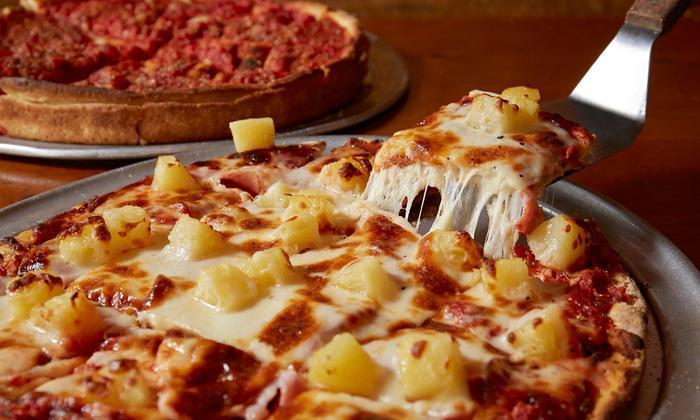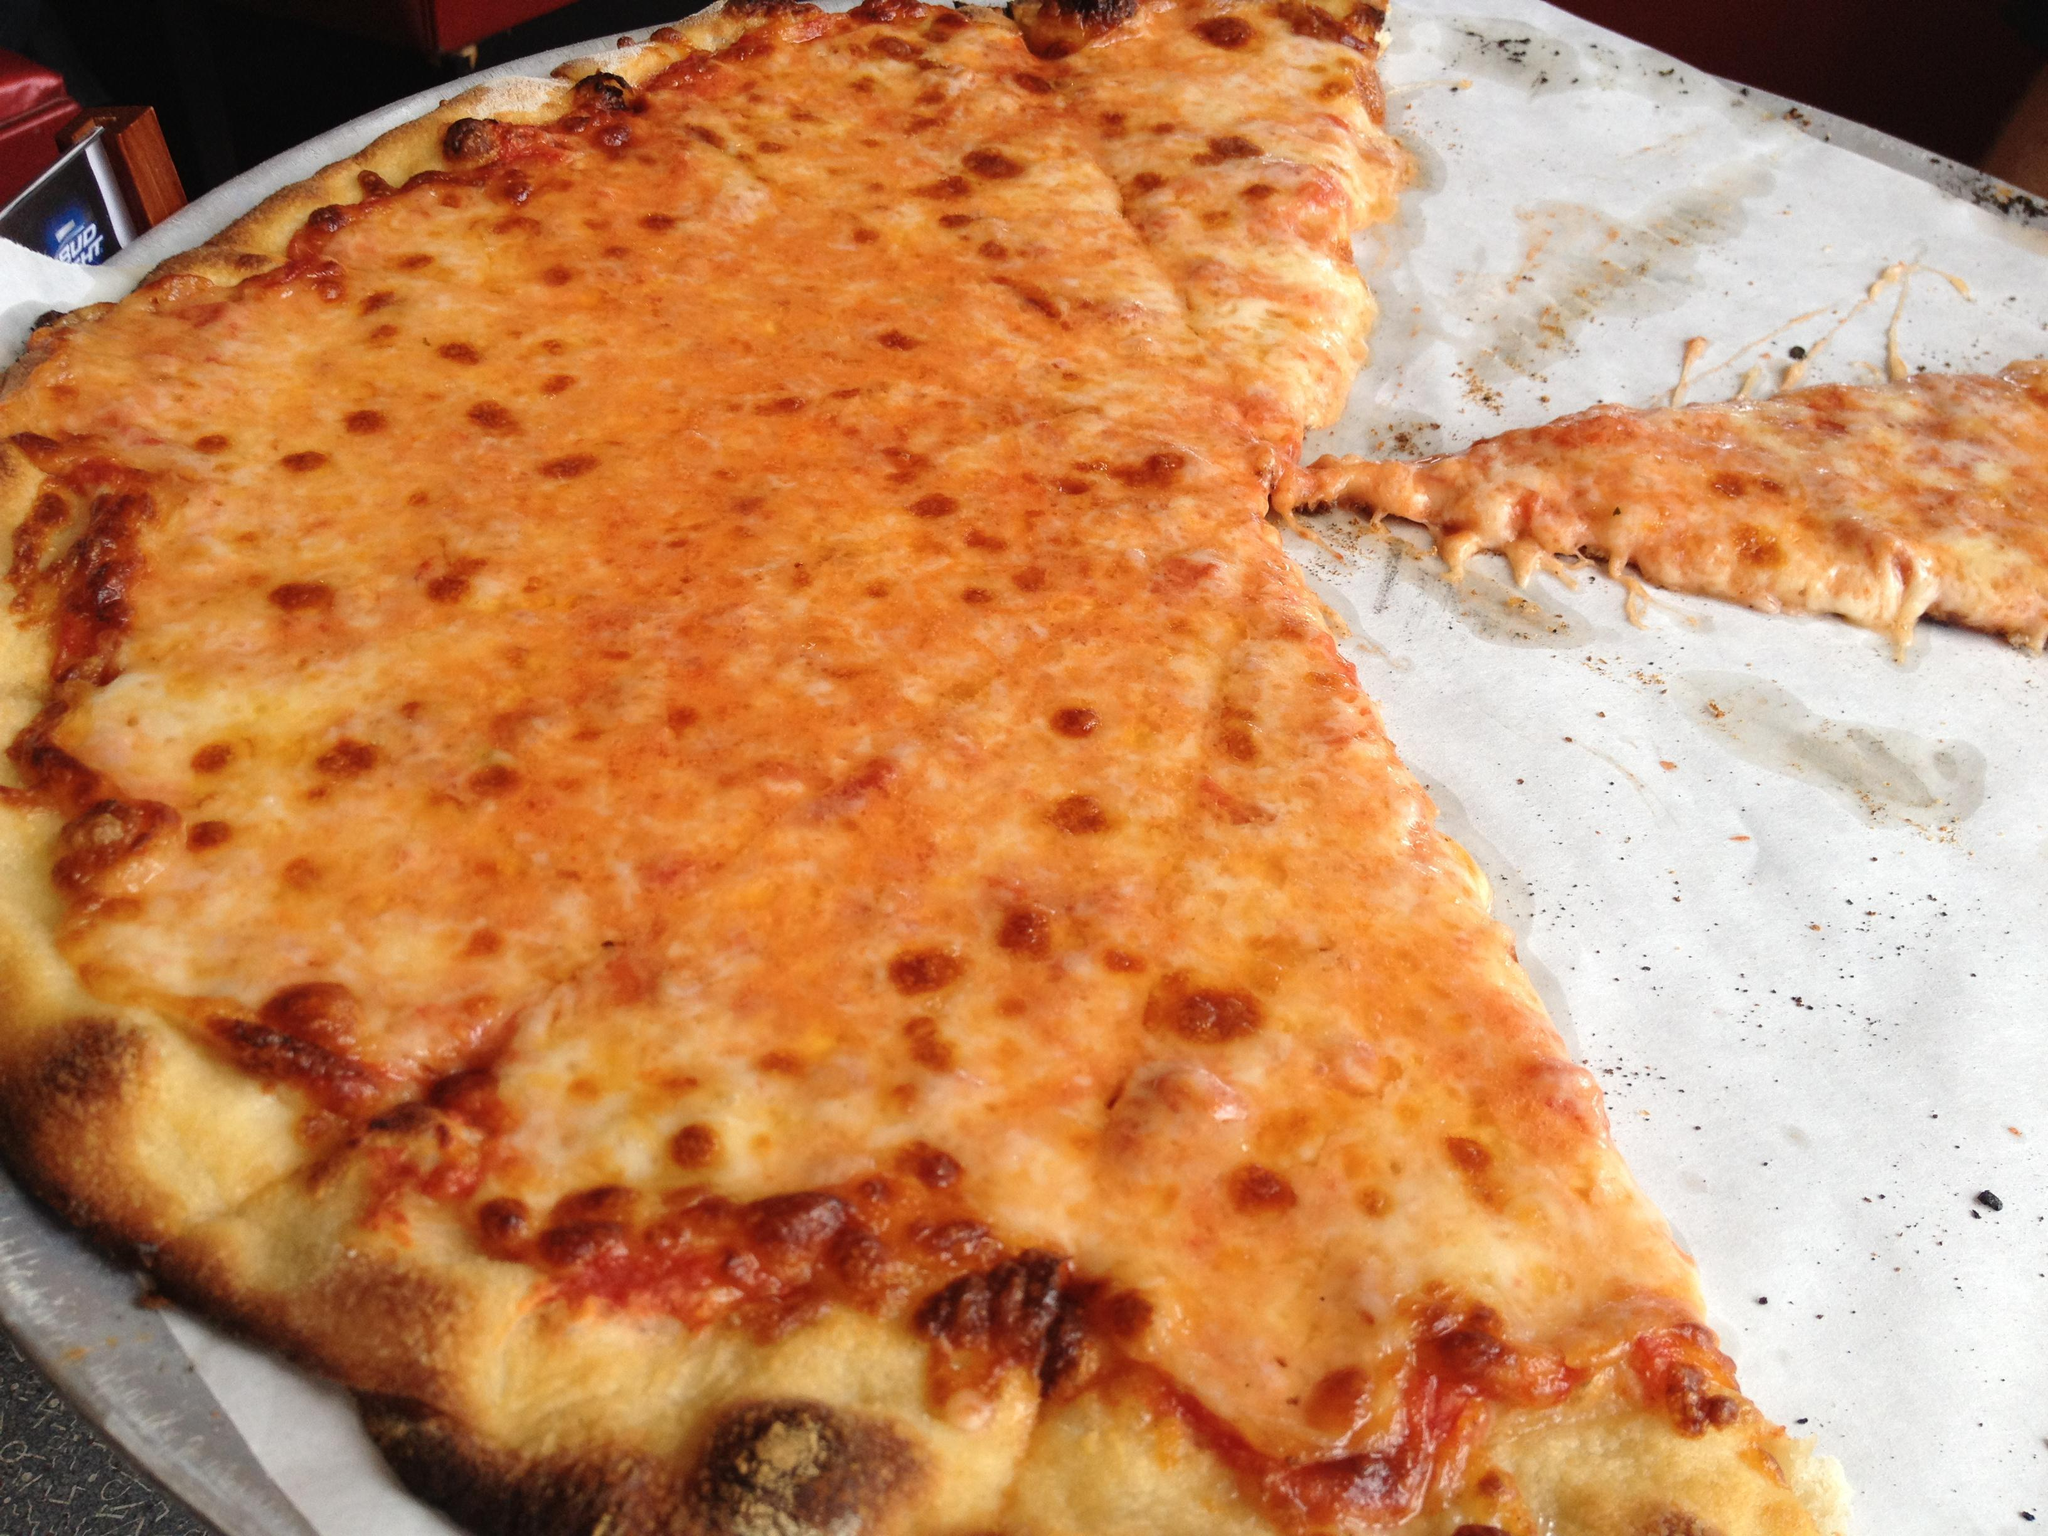The first image is the image on the left, the second image is the image on the right. Analyze the images presented: Is the assertion "The left and right image contains the same number of pizzas with at least on sitting on paper." valid? Answer yes or no. No. The first image is the image on the left, the second image is the image on the right. Analyze the images presented: Is the assertion "The left image shows a tool with a handle and a flat metal part being applied to a round pizza." valid? Answer yes or no. Yes. 